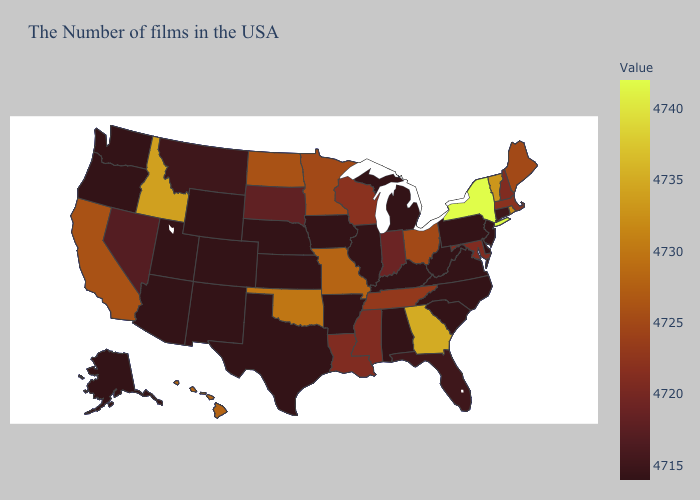Among the states that border New York , which have the highest value?
Concise answer only. Vermont. Does New Hampshire have the lowest value in the Northeast?
Short answer required. No. Which states have the lowest value in the West?
Write a very short answer. Wyoming, Colorado, New Mexico, Utah, Arizona, Washington, Oregon, Alaska. Among the states that border Pennsylvania , which have the lowest value?
Be succinct. New Jersey, Delaware, West Virginia. Does the map have missing data?
Be succinct. No. Does the map have missing data?
Quick response, please. No. Among the states that border Georgia , does South Carolina have the lowest value?
Short answer required. Yes. 